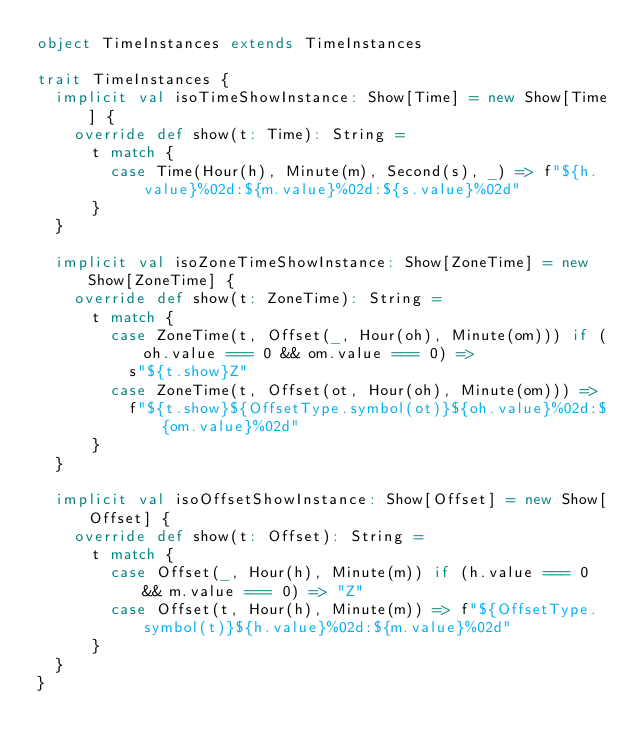Convert code to text. <code><loc_0><loc_0><loc_500><loc_500><_Scala_>object TimeInstances extends TimeInstances

trait TimeInstances {
  implicit val isoTimeShowInstance: Show[Time] = new Show[Time] {
    override def show(t: Time): String =
      t match {
        case Time(Hour(h), Minute(m), Second(s), _) => f"${h.value}%02d:${m.value}%02d:${s.value}%02d"
      }
  }

  implicit val isoZoneTimeShowInstance: Show[ZoneTime] = new Show[ZoneTime] {
    override def show(t: ZoneTime): String =
      t match {
        case ZoneTime(t, Offset(_, Hour(oh), Minute(om))) if (oh.value === 0 && om.value === 0) =>
          s"${t.show}Z"
        case ZoneTime(t, Offset(ot, Hour(oh), Minute(om))) =>
          f"${t.show}${OffsetType.symbol(ot)}${oh.value}%02d:${om.value}%02d"
      }
  }

  implicit val isoOffsetShowInstance: Show[Offset] = new Show[Offset] {
    override def show(t: Offset): String =
      t match {
        case Offset(_, Hour(h), Minute(m)) if (h.value === 0 && m.value === 0) => "Z"
        case Offset(t, Hour(h), Minute(m)) => f"${OffsetType.symbol(t)}${h.value}%02d:${m.value}%02d"
      }
  }
}
</code> 